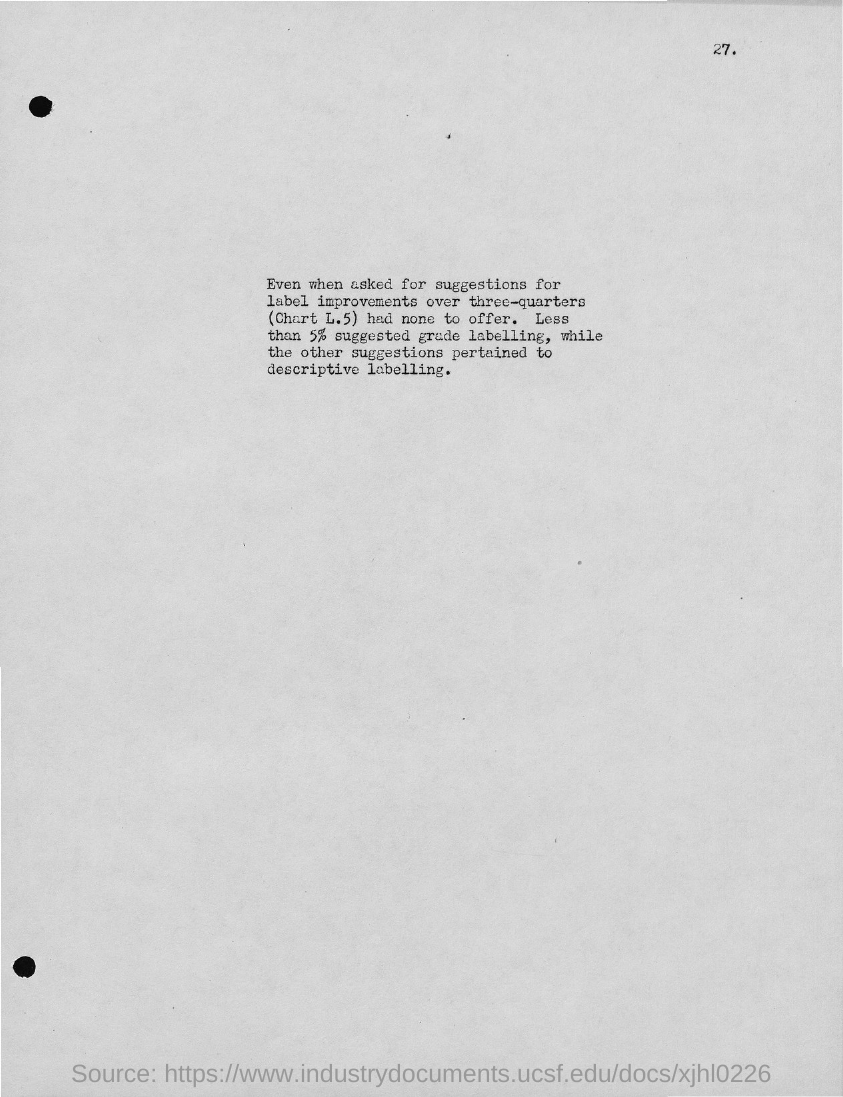What labeling other than grade labeling was pertained?
Provide a succinct answer. DESCRIPTIVE LABELLING. 